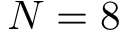Convert formula to latex. <formula><loc_0><loc_0><loc_500><loc_500>N = 8</formula> 